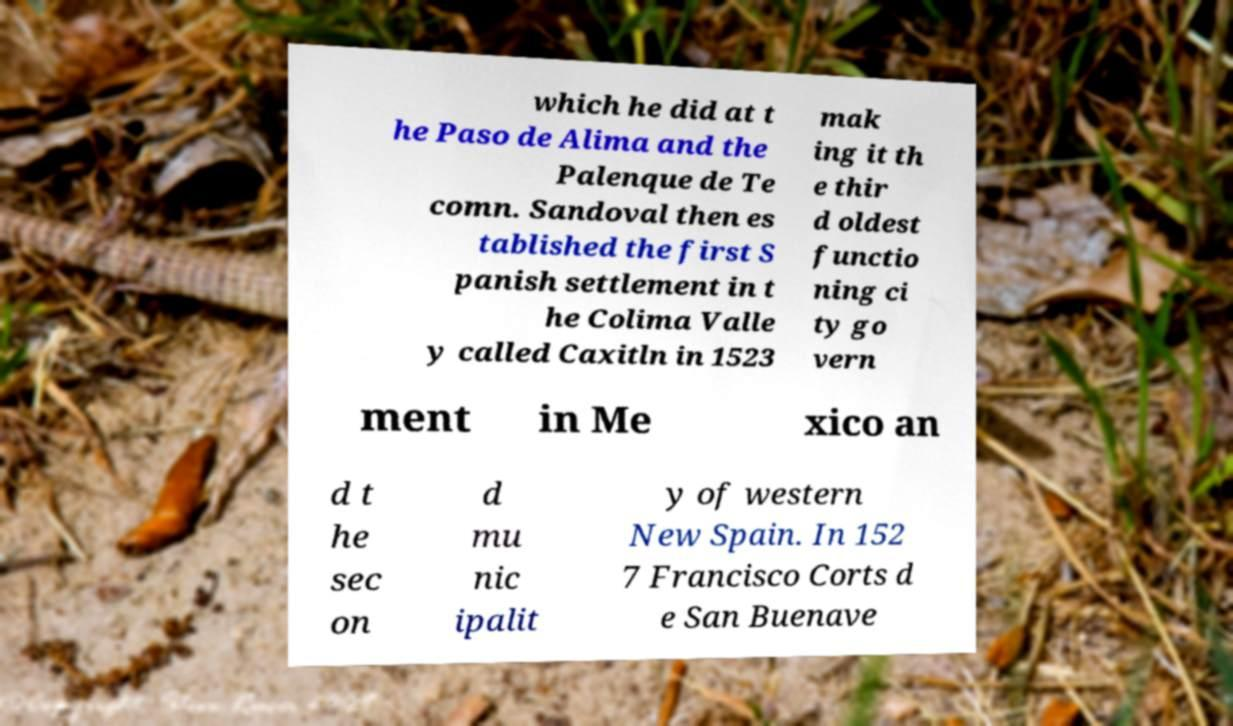I need the written content from this picture converted into text. Can you do that? which he did at t he Paso de Alima and the Palenque de Te comn. Sandoval then es tablished the first S panish settlement in t he Colima Valle y called Caxitln in 1523 mak ing it th e thir d oldest functio ning ci ty go vern ment in Me xico an d t he sec on d mu nic ipalit y of western New Spain. In 152 7 Francisco Corts d e San Buenave 